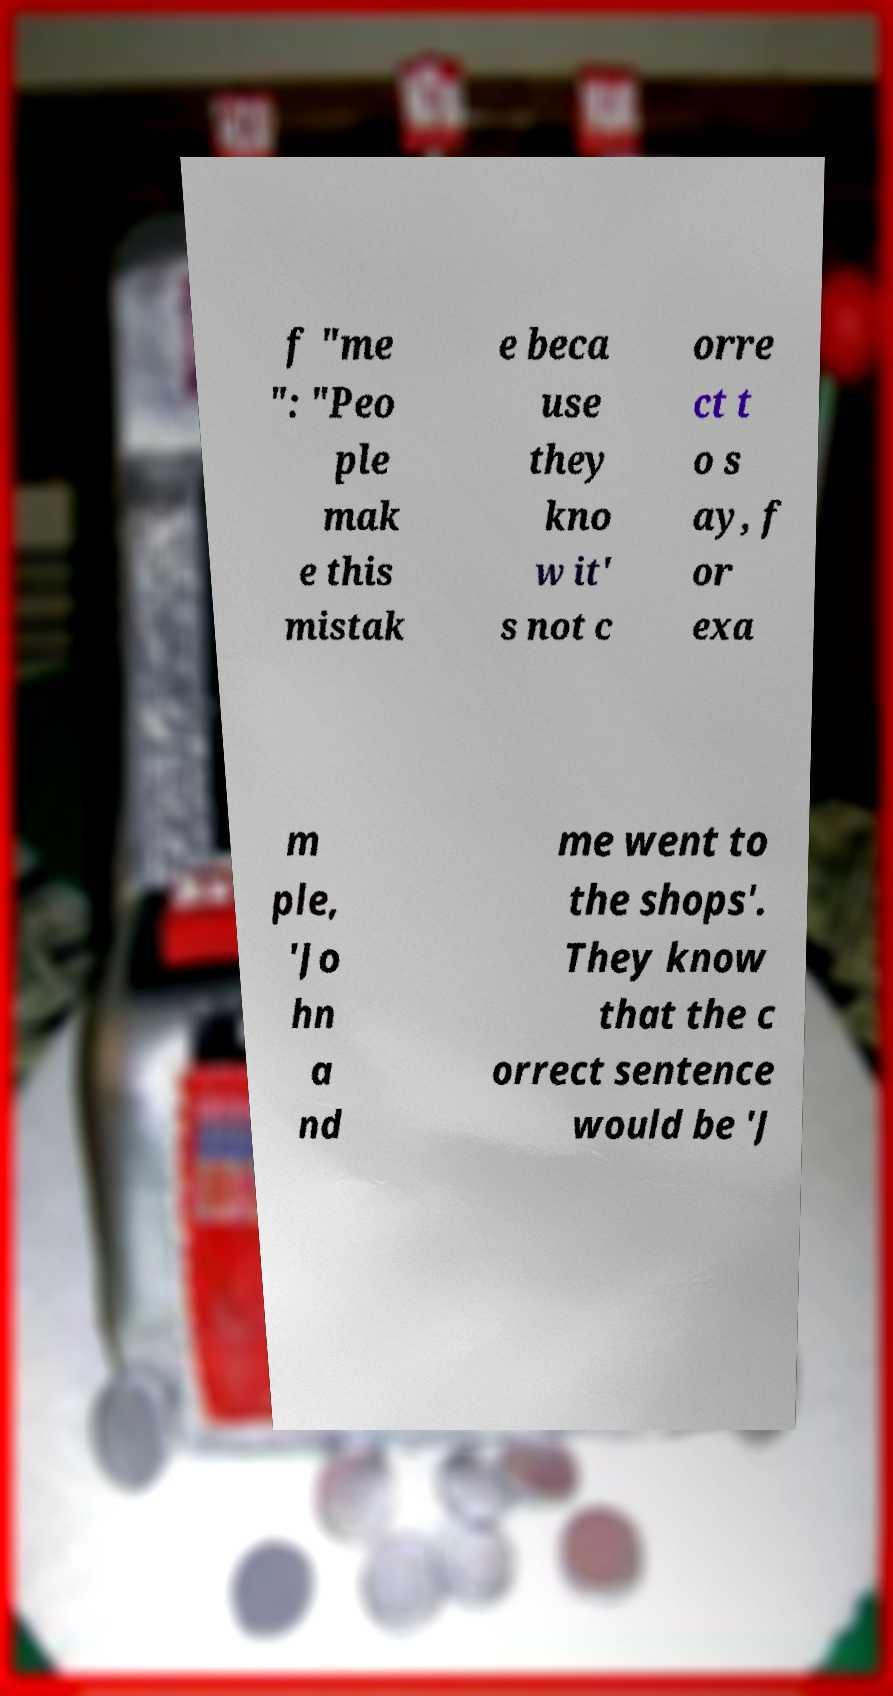Can you accurately transcribe the text from the provided image for me? f "me ": "Peo ple mak e this mistak e beca use they kno w it' s not c orre ct t o s ay, f or exa m ple, 'Jo hn a nd me went to the shops'. They know that the c orrect sentence would be 'J 